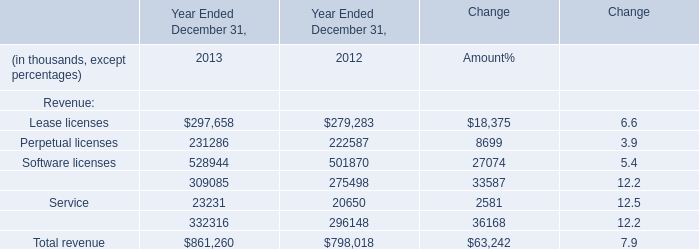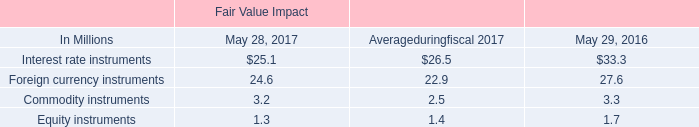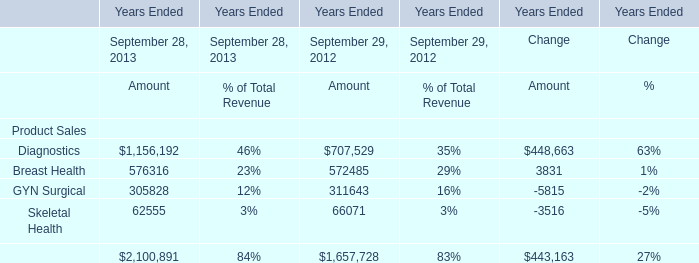What is the total amount of Software licenses of Year Ended December 31, 2013, and Diagnostics of Years Ended Change Amount ? 
Computations: (528944.0 + 448663.0)
Answer: 977607.0. 